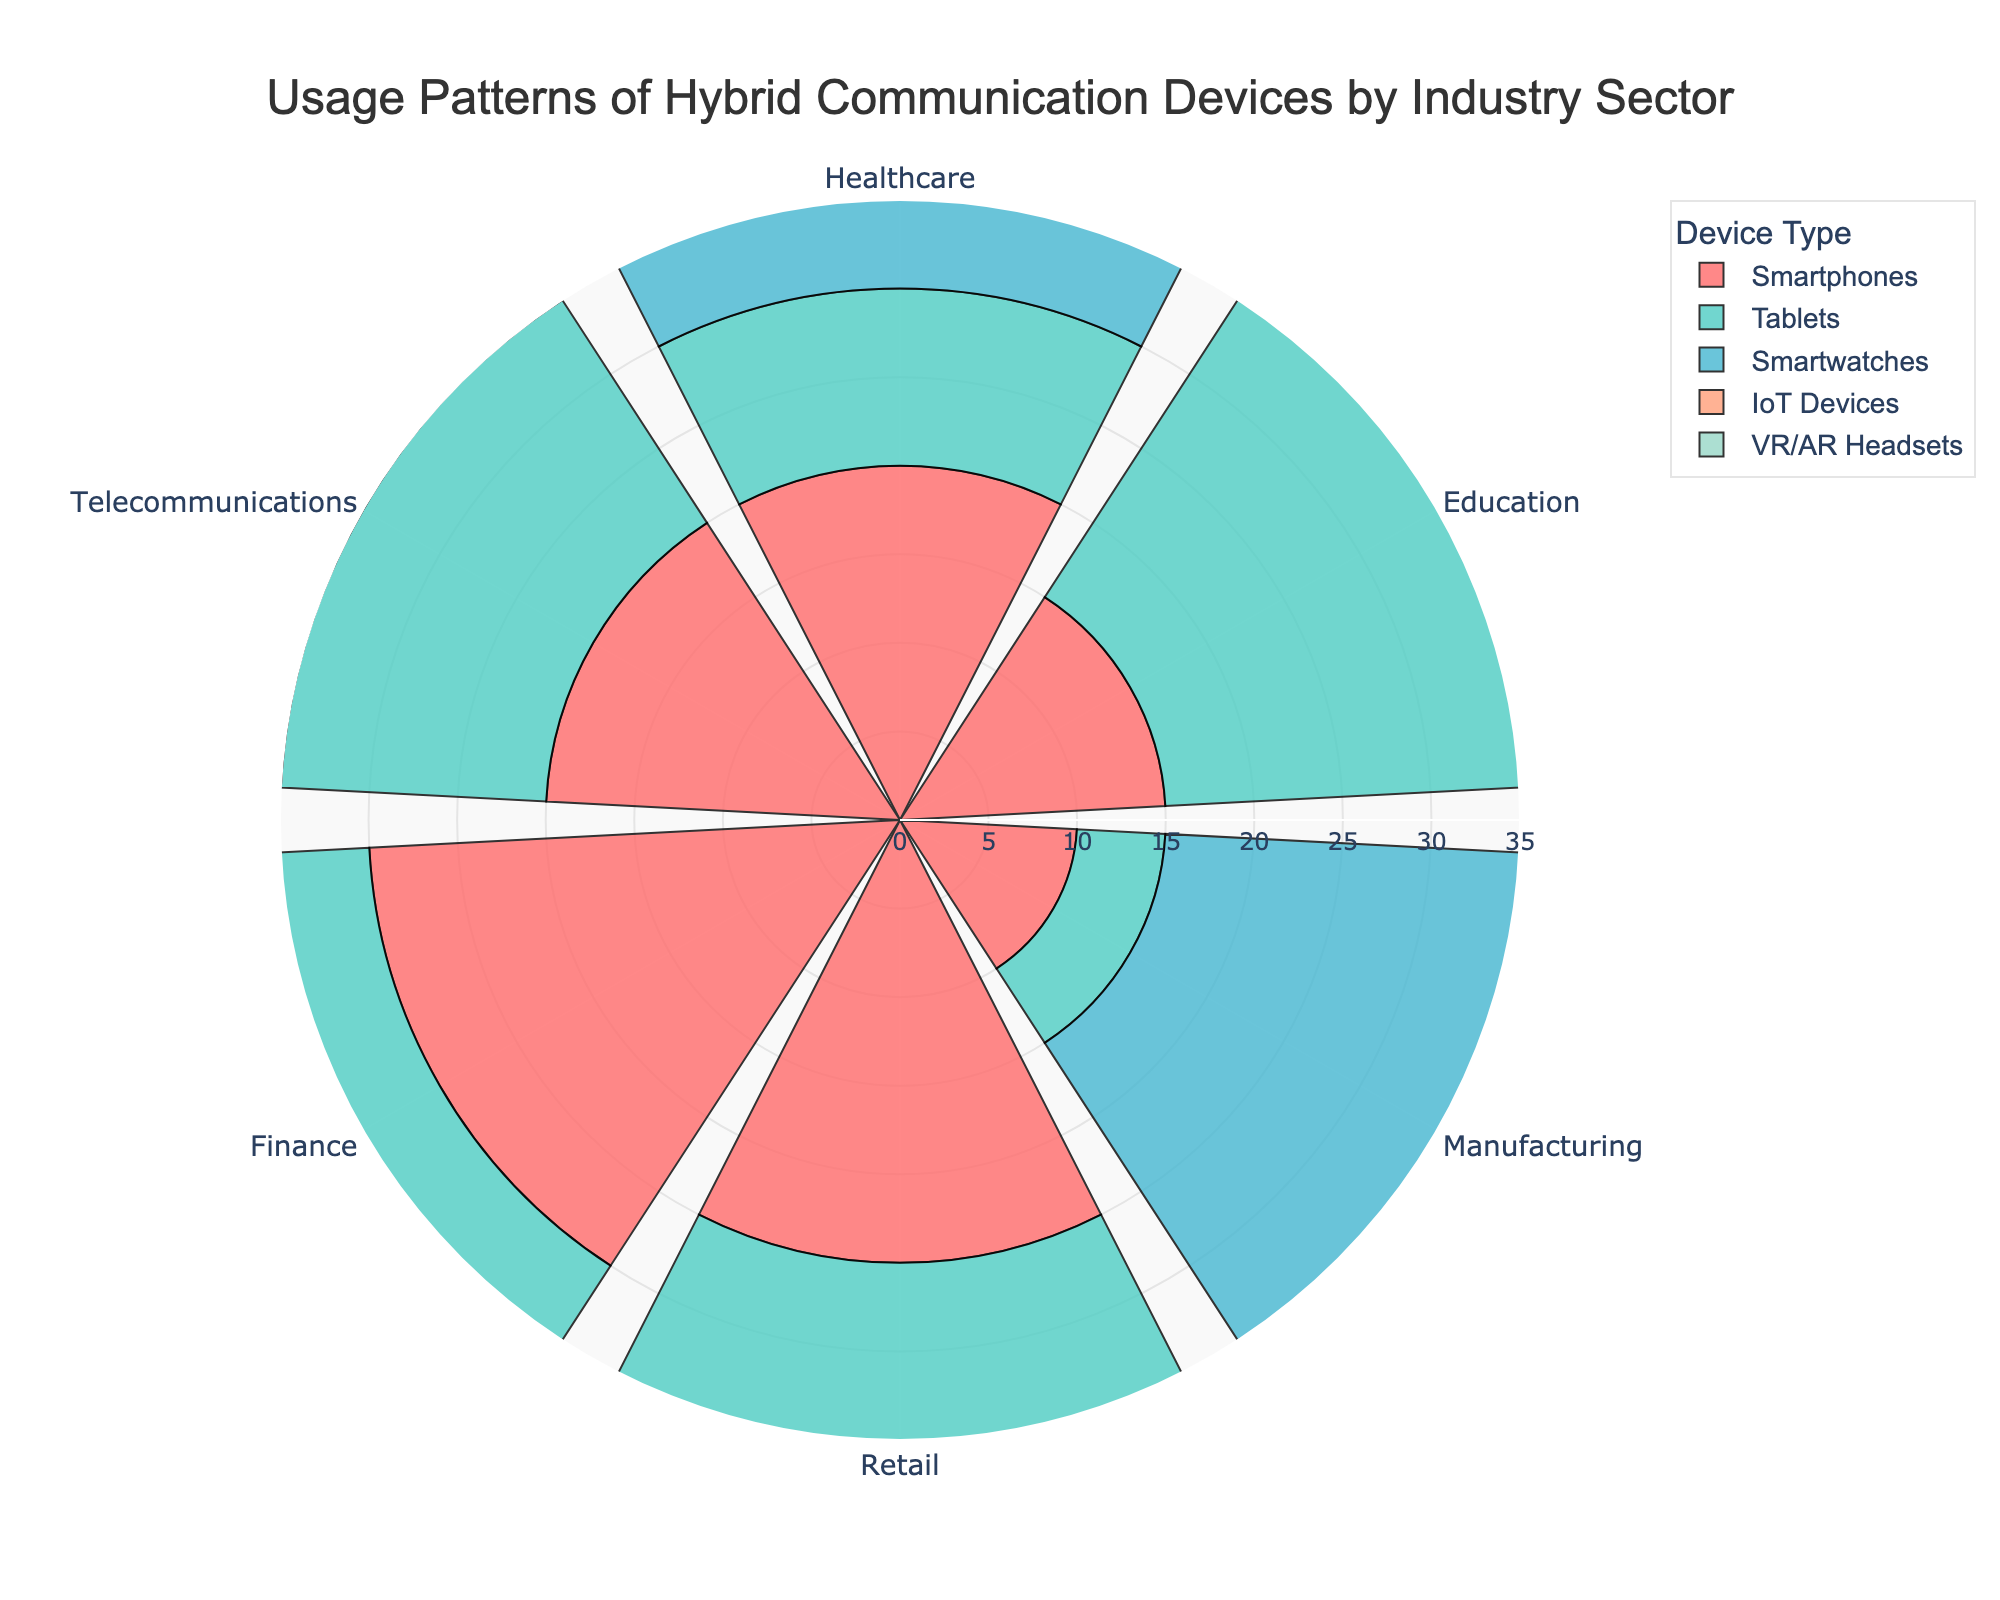What is the title of the chart? The title is typically found at the top or near the top of the chart and summarizes the main topic visually presented. In this case, the title states: "Usage Patterns of Hybrid Communication Devices by Industry Sector."
Answer: Usage Patterns of Hybrid Communication Devices by Industry Sector Which industry sector has the highest usage of tablets? To find this, locate the bar corresponding to tablets for each industry sector and compare their lengths. The bar with the greatest length represents the highest usage. In the chart, the Education sector has the longest bar for tablets.
Answer: Education How many sectors show usage patterns for VR/AR Headsets? Count the number of bars representing VR/AR headsets, identified by their matching color. Every sector in the chart shows a bar for VR/AR headsets, totaling six.
Answer: Six Which device is used most frequently in the Finance sector? Examine and compare the bars representing the Finance sector for each device type; the one with the longest bar indicates the most frequently used device. Here, smartphones have the longest bar for Finance.
Answer: Smartphones What is the difference in smartwatch usage between Healthcare and Finance sectors? Identify the bars for smartwatches in the Healthcare and Finance sectors and find their lengths. For Healthcare, the bar length is 15, and for Finance, it is 5. Subtract the Finance usage from Healthcare usage (15 - 5).
Answer: 10 In which sector is the usage of IoT devices and VR/AR headsets equal? Compare the bars for IoT devices and VR/AR headsets within each sector to see if any pairs of bars are of equal length. In the Retail sector, both bars are of equal length.
Answer: Retail Which device type has the most uniform usage across all sectors? Assess the variance or range of bar lengths for each device type across sectors. Cross-check which device shows the least variation visually. Smartwatches appear to have the most uniform length bars across sectors.
Answer: Smartwatches Which two industry sectors have the most significant difference in smartphone usage? Compare all the bars representing smartphone usage across sectors, and identify the two most extreme lengths. Finance (30) and Manufacturing (10) show the maximum difference. Subtract 10 from 30 to confirm this.
Answer: Finance and Manufacturing What is the total usage of VR/AR headsets across all sectors? Sum the lengths of the VR/AR headset bars for each sector. The lengths are: 5 (Healthcare) + 20 (Education) + 10 (Manufacturing) + 15 (Retail) + 5 (Finance) + 10 (Telecommunications). Add these together: 5 + 20 + 10 + 15 + 5 + 10 = 65.
Answer: 65 